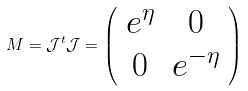Convert formula to latex. <formula><loc_0><loc_0><loc_500><loc_500>M = \mathcal { J } ^ { t } \mathcal { J } = \left ( \begin{array} { c c } e ^ { \eta } & 0 \\ 0 & e ^ { - \eta } \end{array} \right )</formula> 